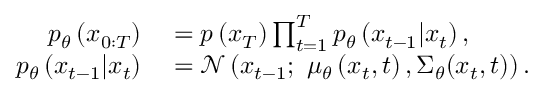Convert formula to latex. <formula><loc_0><loc_0><loc_500><loc_500>\begin{array} { r l } { p _ { \theta } \left ( x _ { 0 \colon T } \right ) } & = p \left ( x _ { T } \right ) \prod _ { t = 1 } ^ { T } p _ { \theta } \left ( x _ { t - 1 } | x _ { t } \right ) , } \\ { p _ { \theta } \left ( x _ { t - 1 } | x _ { t } \right ) } & = \mathcal { N } \left ( x _ { t - 1 } ; \ \mu _ { \theta } \left ( x _ { t } , t \right ) , { { \Sigma } _ { \theta } } ( { { x } _ { t } } , t ) \right ) . } \end{array}</formula> 